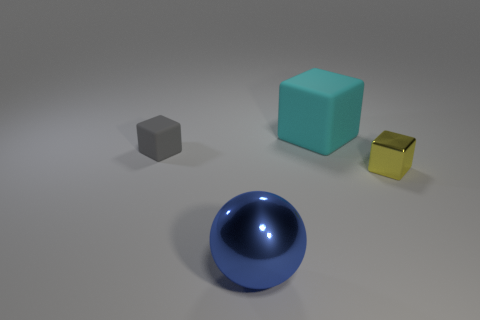Are there the same number of small gray things that are to the right of the tiny gray thing and matte things that are in front of the big cyan cube?
Keep it short and to the point. No. There is a matte thing that is on the left side of the big cyan matte block; is it the same color as the tiny thing that is to the right of the metallic ball?
Keep it short and to the point. No. Are there more small yellow objects left of the yellow block than yellow shiny things?
Ensure brevity in your answer.  No. There is a large cyan thing that is made of the same material as the tiny gray cube; what shape is it?
Offer a very short reply. Cube. There is a thing that is in front of the yellow block; does it have the same size as the tiny matte object?
Keep it short and to the point. No. What is the shape of the shiny object right of the big thing right of the blue metallic thing?
Offer a very short reply. Cube. How big is the metal object that is on the left side of the rubber block that is to the right of the blue metal thing?
Offer a terse response. Large. What color is the tiny cube that is right of the large shiny ball?
Your answer should be compact. Yellow. The object that is the same material as the big block is what size?
Your response must be concise. Small. What number of blue metallic objects are the same shape as the large cyan matte object?
Your answer should be very brief. 0. 